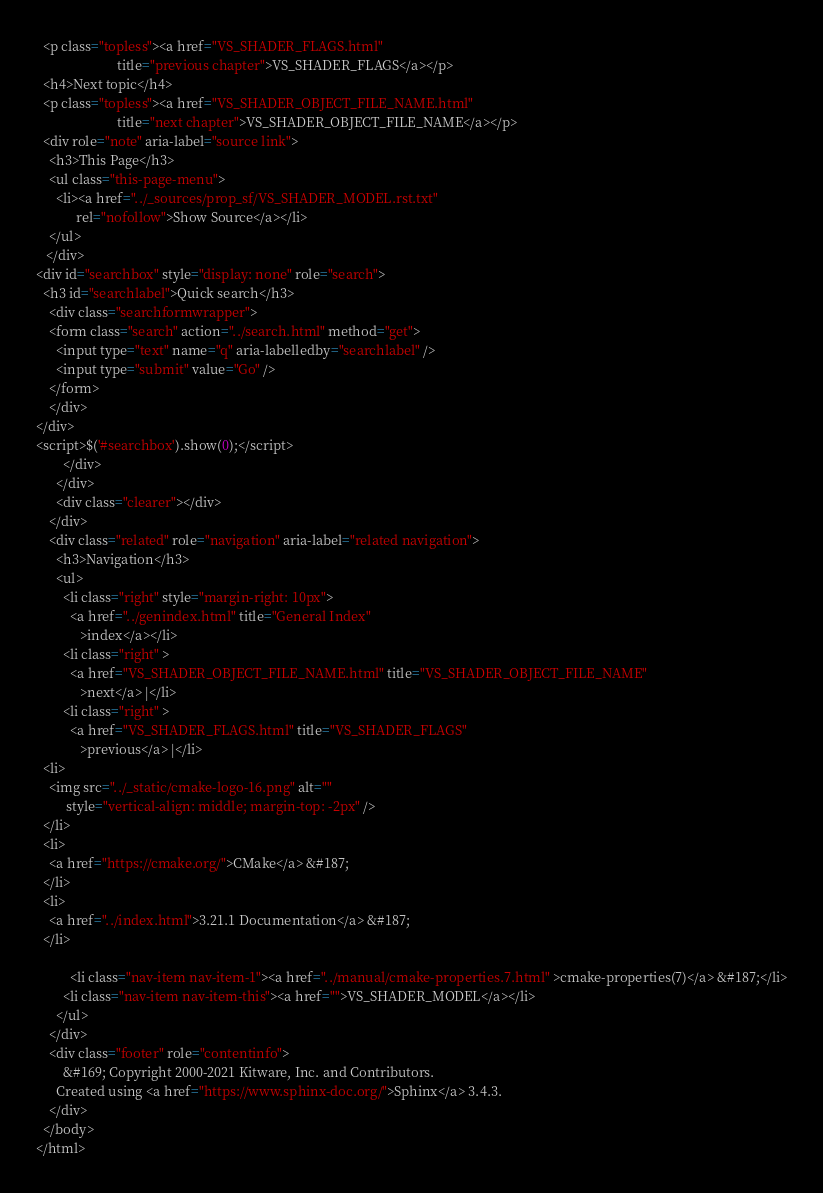Convert code to text. <code><loc_0><loc_0><loc_500><loc_500><_HTML_>  <p class="topless"><a href="VS_SHADER_FLAGS.html"
                        title="previous chapter">VS_SHADER_FLAGS</a></p>
  <h4>Next topic</h4>
  <p class="topless"><a href="VS_SHADER_OBJECT_FILE_NAME.html"
                        title="next chapter">VS_SHADER_OBJECT_FILE_NAME</a></p>
  <div role="note" aria-label="source link">
    <h3>This Page</h3>
    <ul class="this-page-menu">
      <li><a href="../_sources/prop_sf/VS_SHADER_MODEL.rst.txt"
            rel="nofollow">Show Source</a></li>
    </ul>
   </div>
<div id="searchbox" style="display: none" role="search">
  <h3 id="searchlabel">Quick search</h3>
    <div class="searchformwrapper">
    <form class="search" action="../search.html" method="get">
      <input type="text" name="q" aria-labelledby="searchlabel" />
      <input type="submit" value="Go" />
    </form>
    </div>
</div>
<script>$('#searchbox').show(0);</script>
        </div>
      </div>
      <div class="clearer"></div>
    </div>
    <div class="related" role="navigation" aria-label="related navigation">
      <h3>Navigation</h3>
      <ul>
        <li class="right" style="margin-right: 10px">
          <a href="../genindex.html" title="General Index"
             >index</a></li>
        <li class="right" >
          <a href="VS_SHADER_OBJECT_FILE_NAME.html" title="VS_SHADER_OBJECT_FILE_NAME"
             >next</a> |</li>
        <li class="right" >
          <a href="VS_SHADER_FLAGS.html" title="VS_SHADER_FLAGS"
             >previous</a> |</li>
  <li>
    <img src="../_static/cmake-logo-16.png" alt=""
         style="vertical-align: middle; margin-top: -2px" />
  </li>
  <li>
    <a href="https://cmake.org/">CMake</a> &#187;
  </li>
  <li>
    <a href="../index.html">3.21.1 Documentation</a> &#187;
  </li>

          <li class="nav-item nav-item-1"><a href="../manual/cmake-properties.7.html" >cmake-properties(7)</a> &#187;</li>
        <li class="nav-item nav-item-this"><a href="">VS_SHADER_MODEL</a></li> 
      </ul>
    </div>
    <div class="footer" role="contentinfo">
        &#169; Copyright 2000-2021 Kitware, Inc. and Contributors.
      Created using <a href="https://www.sphinx-doc.org/">Sphinx</a> 3.4.3.
    </div>
  </body>
</html></code> 